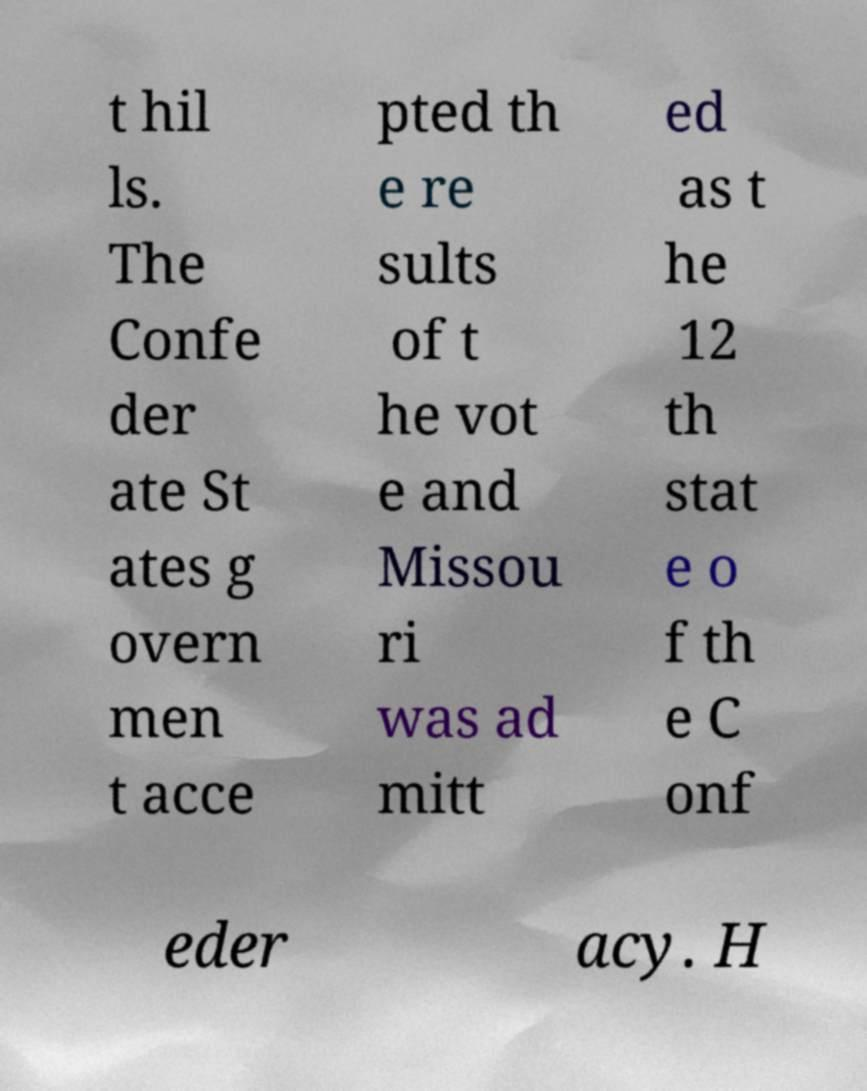I need the written content from this picture converted into text. Can you do that? t hil ls. The Confe der ate St ates g overn men t acce pted th e re sults of t he vot e and Missou ri was ad mitt ed as t he 12 th stat e o f th e C onf eder acy. H 